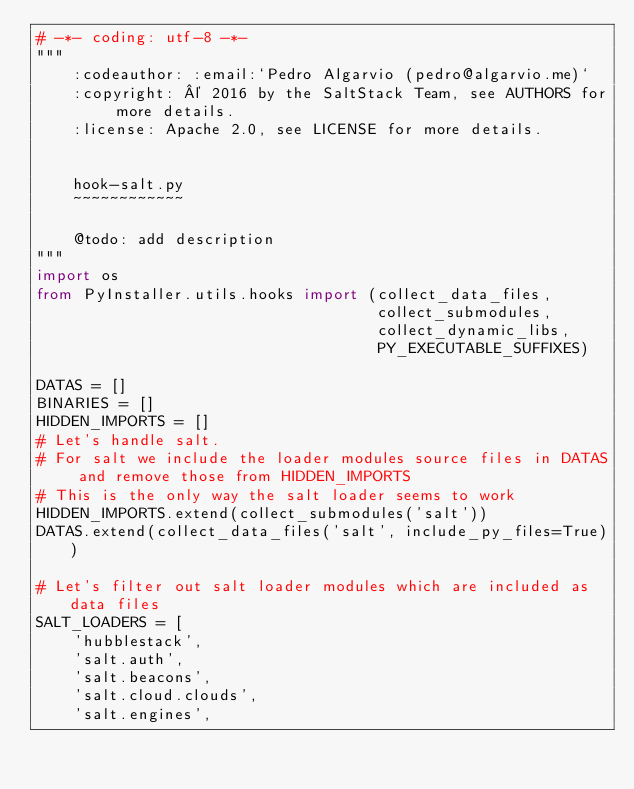Convert code to text. <code><loc_0><loc_0><loc_500><loc_500><_Python_># -*- coding: utf-8 -*-
"""
    :codeauthor: :email:`Pedro Algarvio (pedro@algarvio.me)`
    :copyright: © 2016 by the SaltStack Team, see AUTHORS for more details.
    :license: Apache 2.0, see LICENSE for more details.


    hook-salt.py
    ~~~~~~~~~~~~

    @todo: add description
"""
import os
from PyInstaller.utils.hooks import (collect_data_files,
                                     collect_submodules,
                                     collect_dynamic_libs,
                                     PY_EXECUTABLE_SUFFIXES)

DATAS = []
BINARIES = []
HIDDEN_IMPORTS = []
# Let's handle salt.
# For salt we include the loader modules source files in DATAS and remove those from HIDDEN_IMPORTS
# This is the only way the salt loader seems to work
HIDDEN_IMPORTS.extend(collect_submodules('salt'))
DATAS.extend(collect_data_files('salt', include_py_files=True))

# Let's filter out salt loader modules which are included as data files
SALT_LOADERS = [
    'hubblestack',
    'salt.auth',
    'salt.beacons',
    'salt.cloud.clouds',
    'salt.engines',</code> 